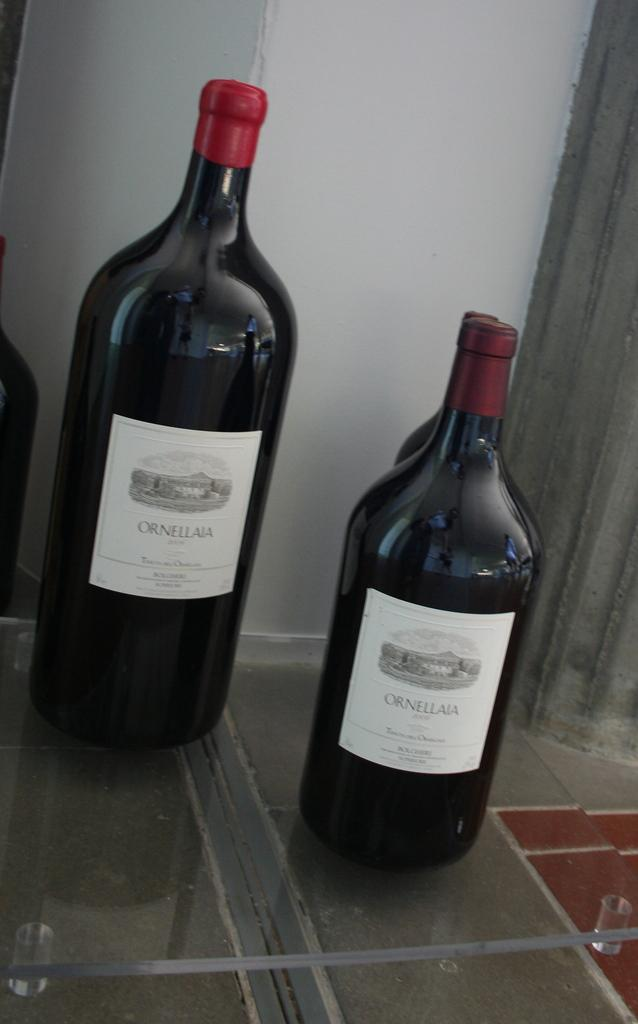Provide a one-sentence caption for the provided image. Two wine bottles from Ornellaia on the counter. 